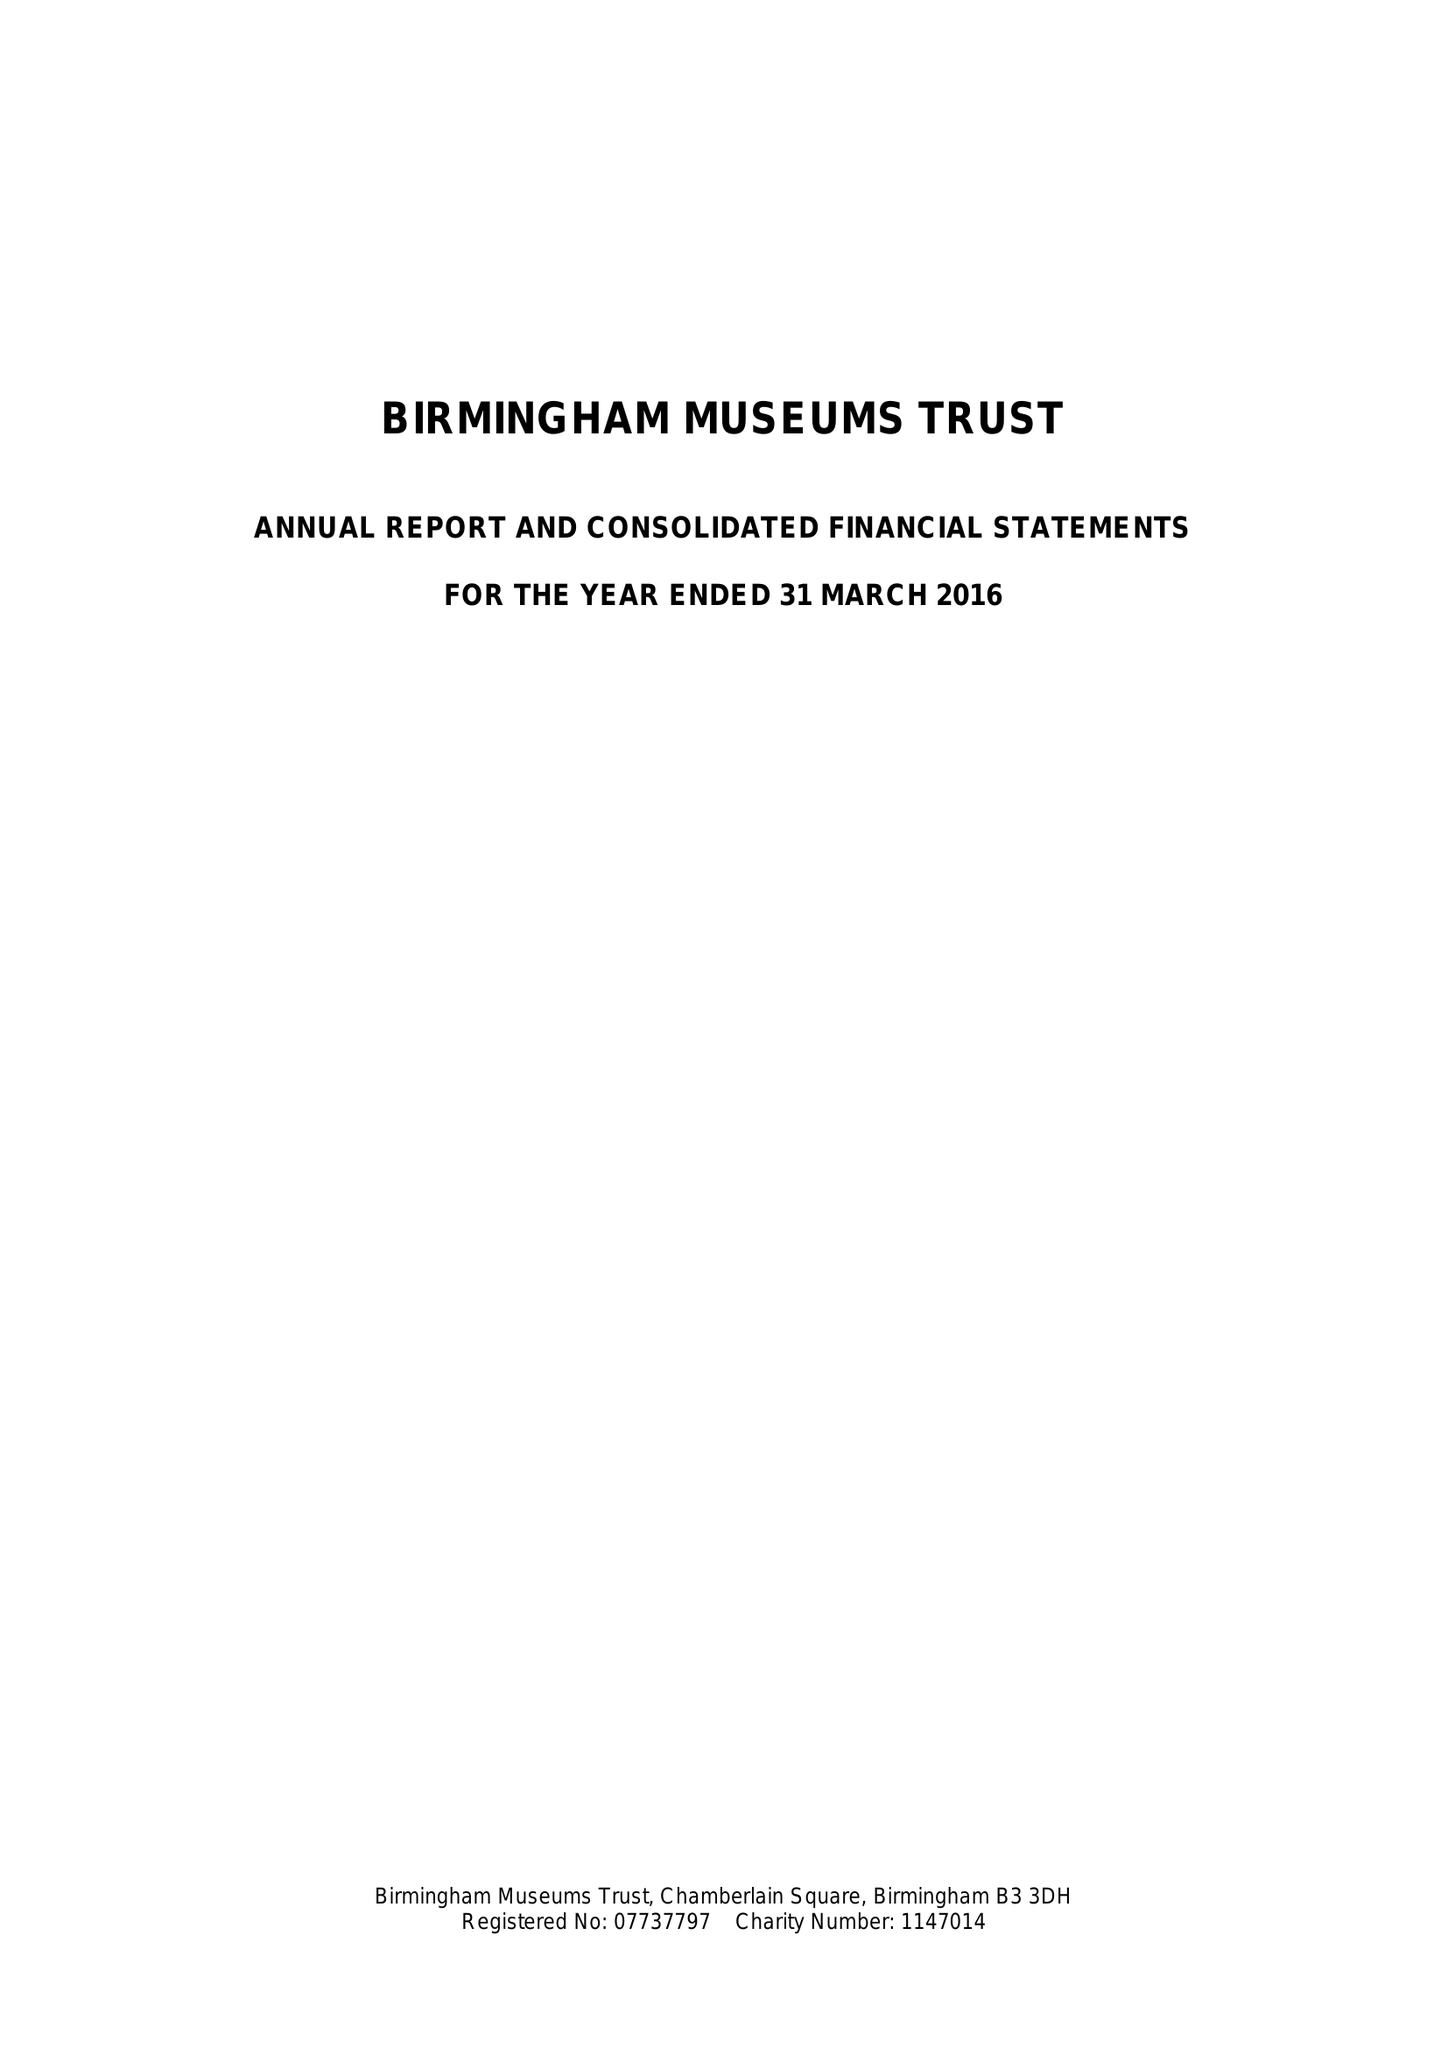What is the value for the report_date?
Answer the question using a single word or phrase. 2016-03-31 